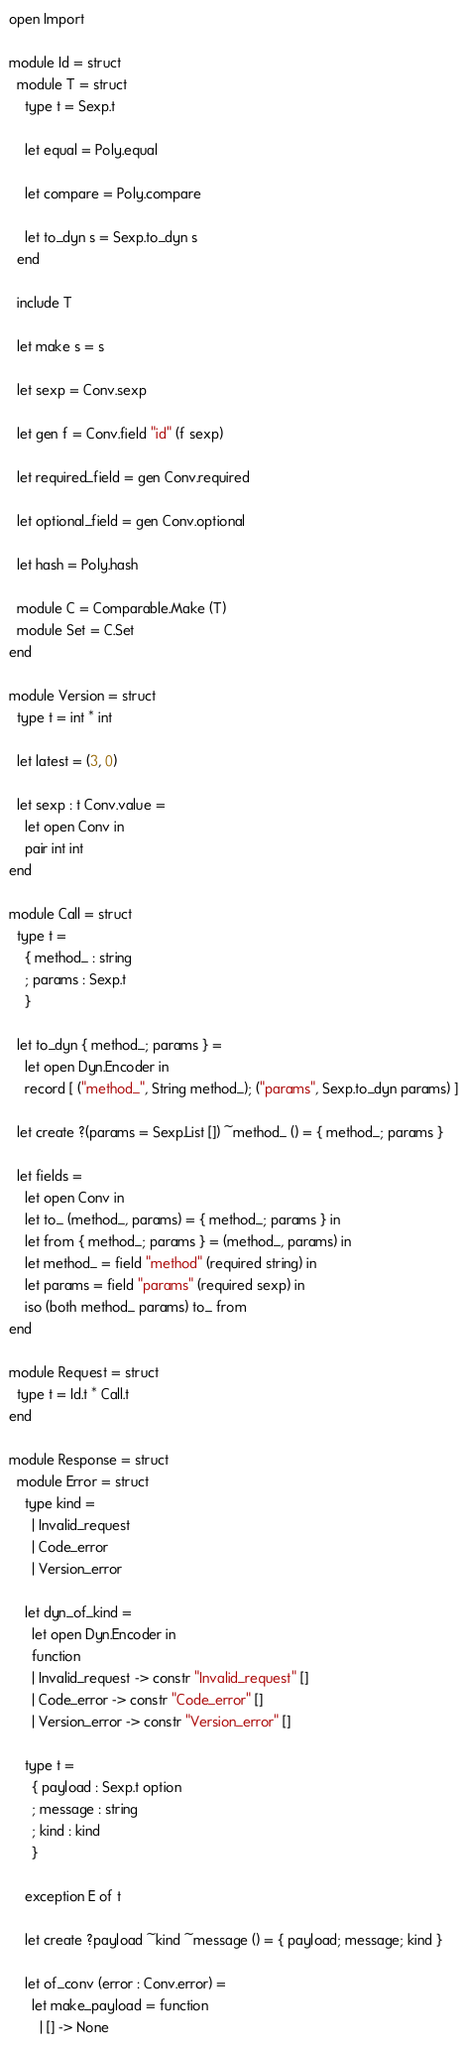Convert code to text. <code><loc_0><loc_0><loc_500><loc_500><_OCaml_>open Import

module Id = struct
  module T = struct
    type t = Sexp.t

    let equal = Poly.equal

    let compare = Poly.compare

    let to_dyn s = Sexp.to_dyn s
  end

  include T

  let make s = s

  let sexp = Conv.sexp

  let gen f = Conv.field "id" (f sexp)

  let required_field = gen Conv.required

  let optional_field = gen Conv.optional

  let hash = Poly.hash

  module C = Comparable.Make (T)
  module Set = C.Set
end

module Version = struct
  type t = int * int

  let latest = (3, 0)

  let sexp : t Conv.value =
    let open Conv in
    pair int int
end

module Call = struct
  type t =
    { method_ : string
    ; params : Sexp.t
    }

  let to_dyn { method_; params } =
    let open Dyn.Encoder in
    record [ ("method_", String method_); ("params", Sexp.to_dyn params) ]

  let create ?(params = Sexp.List []) ~method_ () = { method_; params }

  let fields =
    let open Conv in
    let to_ (method_, params) = { method_; params } in
    let from { method_; params } = (method_, params) in
    let method_ = field "method" (required string) in
    let params = field "params" (required sexp) in
    iso (both method_ params) to_ from
end

module Request = struct
  type t = Id.t * Call.t
end

module Response = struct
  module Error = struct
    type kind =
      | Invalid_request
      | Code_error
      | Version_error

    let dyn_of_kind =
      let open Dyn.Encoder in
      function
      | Invalid_request -> constr "Invalid_request" []
      | Code_error -> constr "Code_error" []
      | Version_error -> constr "Version_error" []

    type t =
      { payload : Sexp.t option
      ; message : string
      ; kind : kind
      }

    exception E of t

    let create ?payload ~kind ~message () = { payload; message; kind }

    let of_conv (error : Conv.error) =
      let make_payload = function
        | [] -> None</code> 